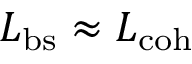Convert formula to latex. <formula><loc_0><loc_0><loc_500><loc_500>L _ { b s } \approx L _ { c o h }</formula> 